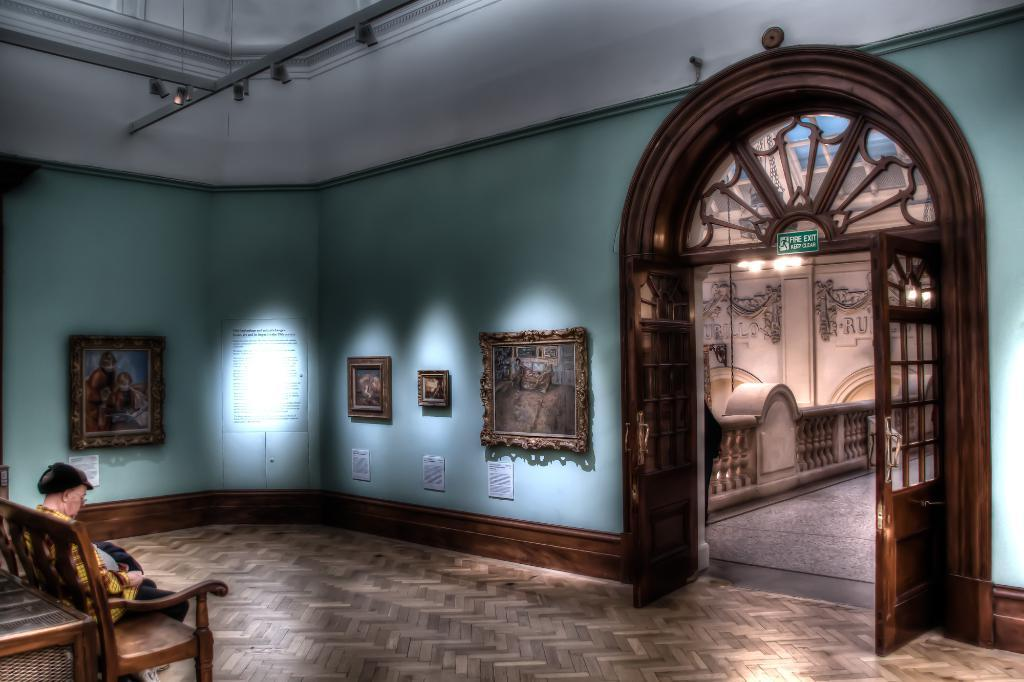What is the person in the image doing? The person is sitting on a chair in the room. Where is the person located in the room? The person is on the left side of the room. What can be seen on the walls in the room? There are frames on the wall in the room. What is the entrance to the room like? There is an entry door on the right side of the room. What is used to illuminate the room? There are lights in the room. How many kittens are playing with the person's flesh in the image? There are no kittens or any reference to flesh in the image; it only shows a person sitting on a chair in a room. 